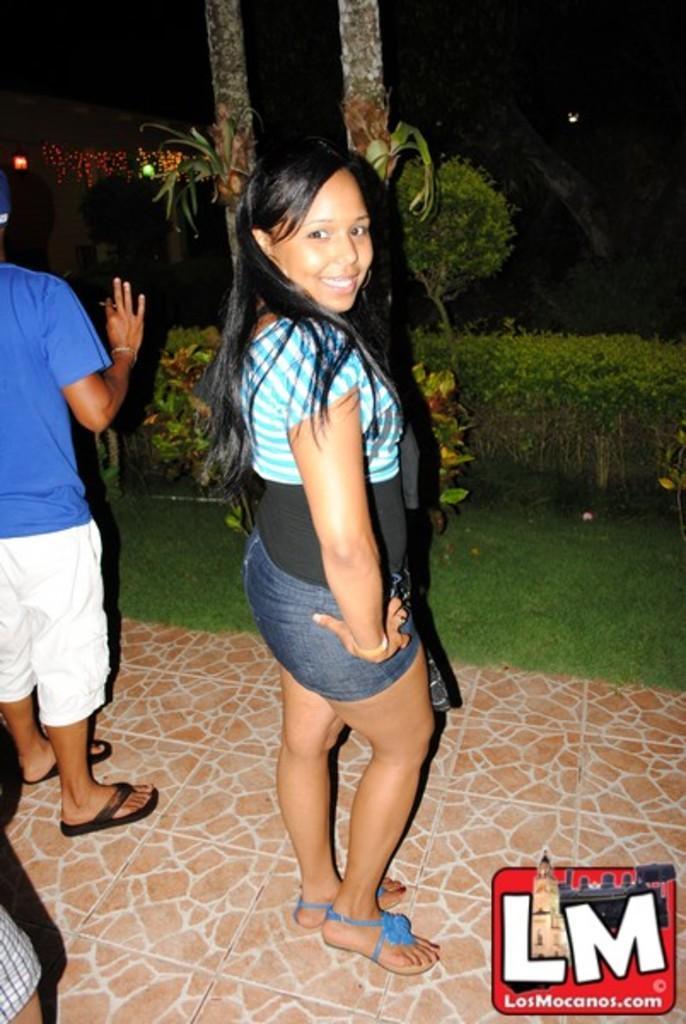Could you give a brief overview of what you see in this image? In this picture I can see few people are standing and I can see trees and plants in the back and I can see a dark background and a logo at the bottom right corner of the picture. 